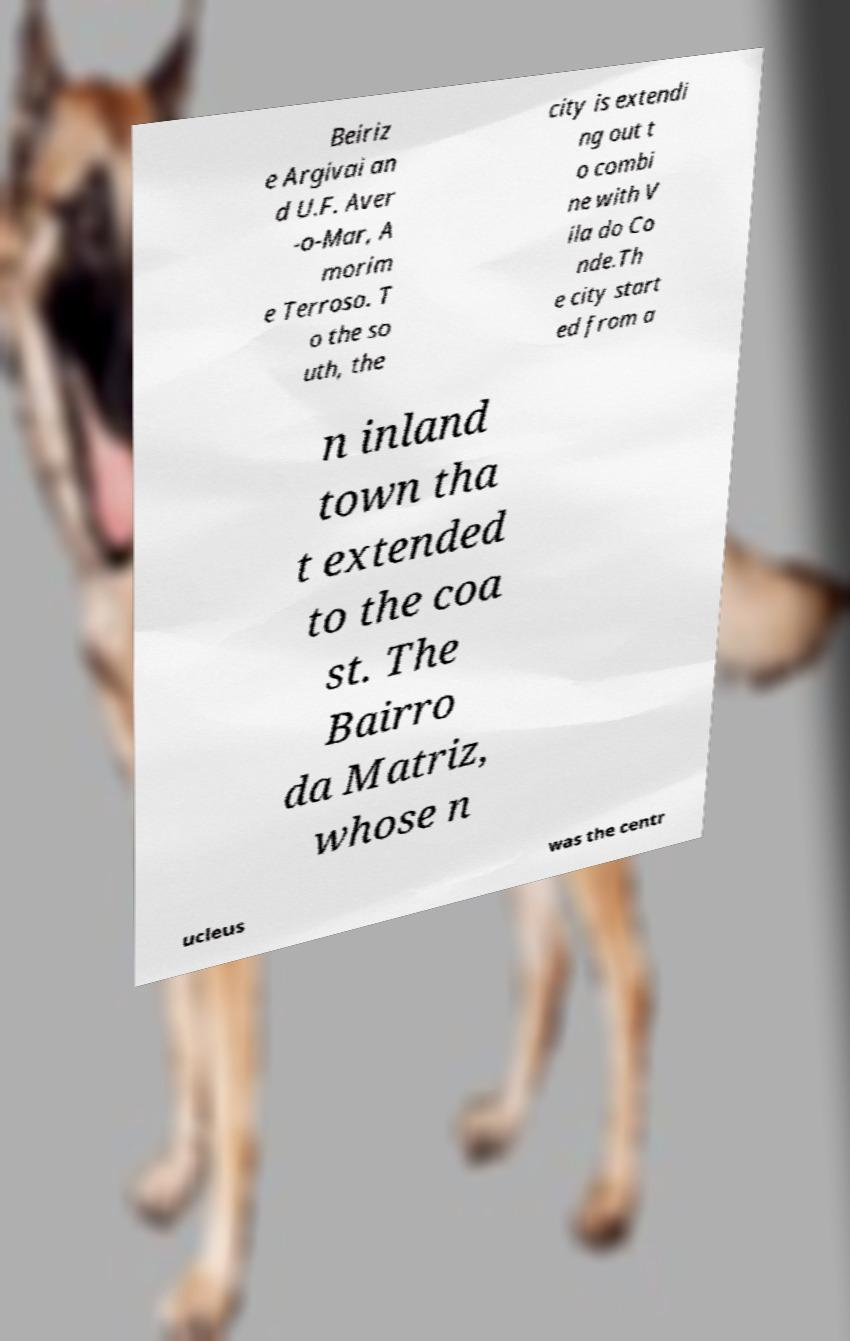Could you assist in decoding the text presented in this image and type it out clearly? Beiriz e Argivai an d U.F. Aver -o-Mar, A morim e Terroso. T o the so uth, the city is extendi ng out t o combi ne with V ila do Co nde.Th e city start ed from a n inland town tha t extended to the coa st. The Bairro da Matriz, whose n ucleus was the centr 